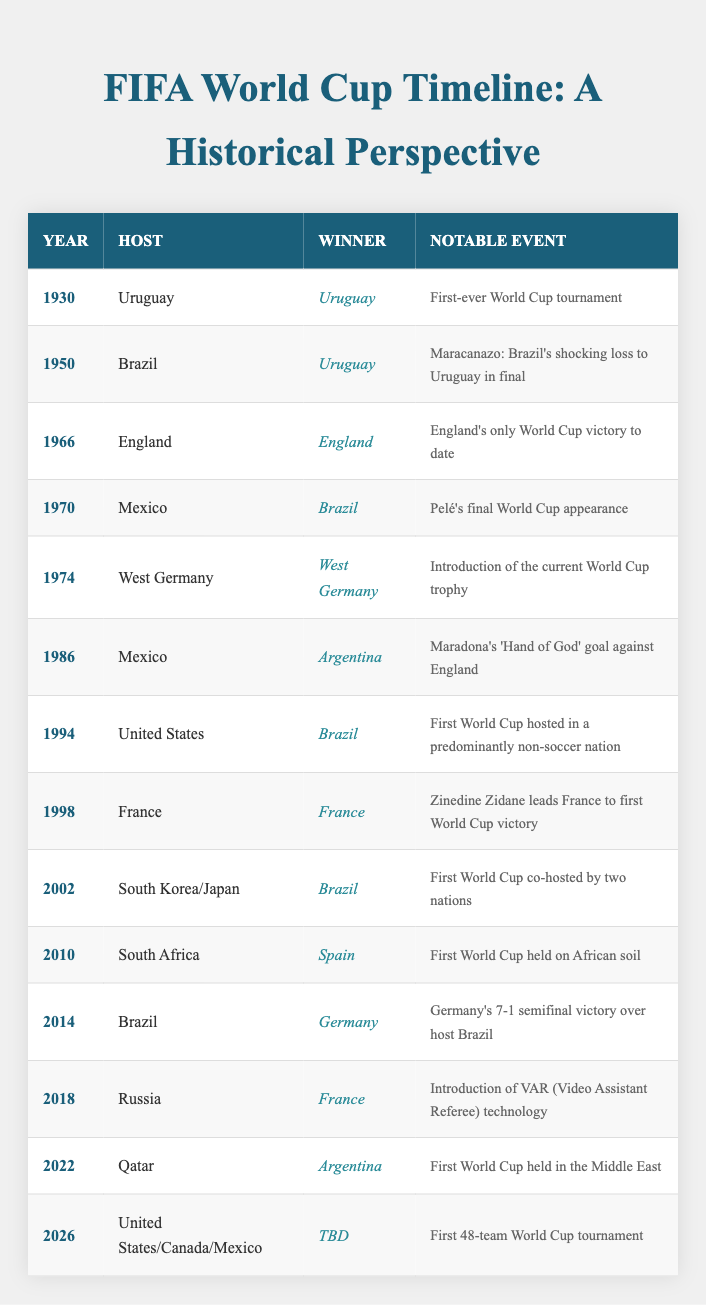What year did Uruguay win their first World Cup? The first World Cup took place in 1930, and Uruguay was the winner.
Answer: 1930 Which country hosted the World Cup in 1994? The table indicates that the United States hosted the World Cup in 1994.
Answer: United States How many times has Brazil hosted the World Cup? Brazil is listed as the host in two years: 1950 and 2014, so it has hosted the tournament twice.
Answer: 2 Was the World Cup held in Africa before 2010? The table shows that the first World Cup held on African soil was in 2010, meaning it was not held in Africa before that year.
Answer: No What notable event occurred during the World Cup in 1986? The notable event for the 1986 tournament was Maradona's 'Hand of God' goal against England, as listed in the table.
Answer: Maradona's 'Hand of God' goal What is the winner's name for the World Cup in 2026? The table indicates that the winner for the 2026 World Cup is currently to be determined, hence there is no winner listed yet.
Answer: TBD How many tournaments listed in the table were hosted in Mexico? Mexico hosted the World Cup in two different years: 1970 and 1986, so there are two tournaments hosted there as shown in the table.
Answer: 2 What notable event took place during the World Cup in 2018? The data specifies that the notable event in 2018 was the introduction of VAR (Video Assistant Referee) technology, highlighting an important technological advance in the tournament.
Answer: Introduction of VAR technology Which country won the World Cup in 1966 and how is it significant? The winner of the World Cup in 1966 was England, and this is significant as it marks England's only World Cup victory to date, as stated in the notable events column.
Answer: England, only victory to date 